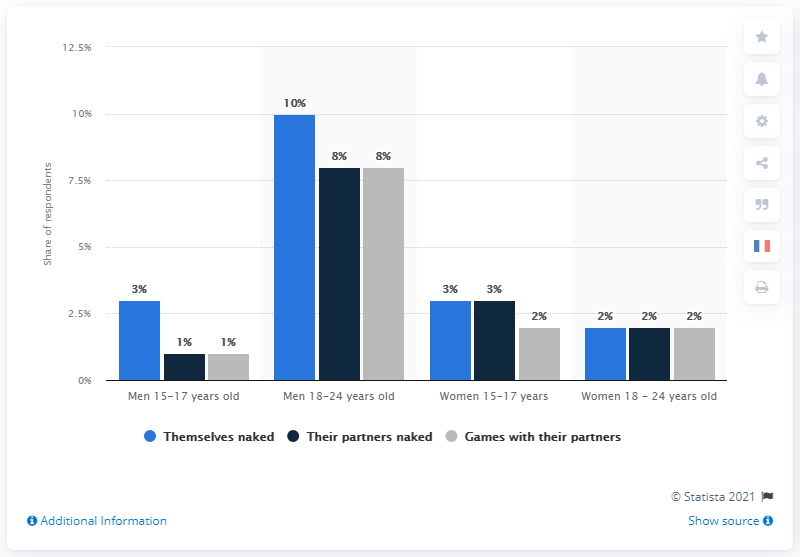Draw attention to some important aspects in this diagram. In 2013, approximately 10% of men between the ages of 18 and 24 reported having published naked pictures of themselves. It is estimated that there is a ratio of 4 out of every 10 men and women between the ages of 18 and 24 who are willing to strip down and be naked. The sum of percentages among men in the age group of 18-24 years old is 26%. 